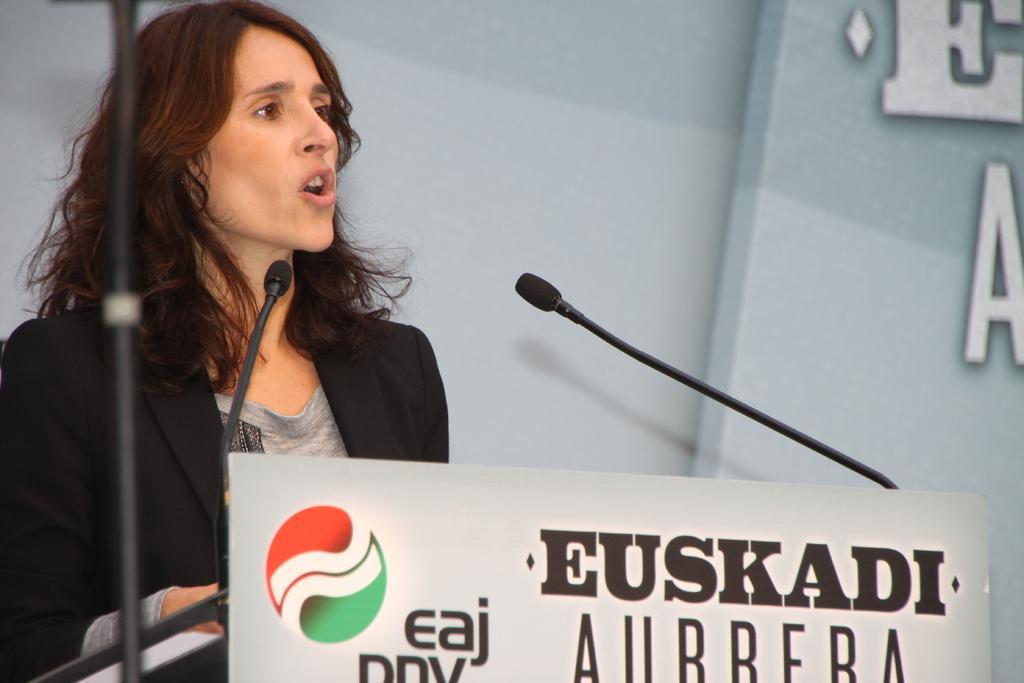Could you give a brief overview of what you see in this image? In this image, we can see a person and some microphones. We can also see a poster with some text and image. We can also see the background with some text. We can also see a black colored object. 